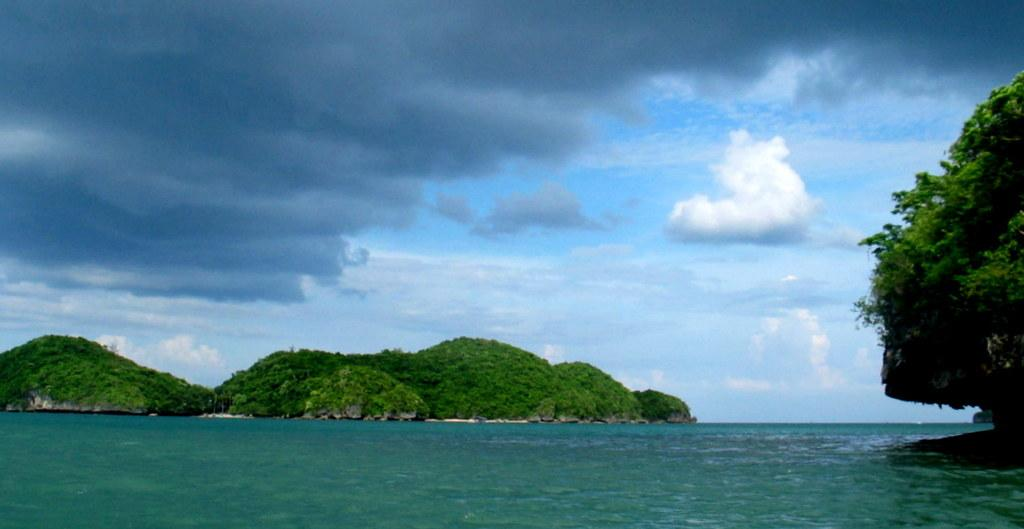What is the primary element visible in the image? There is water in the image. What type of landscape can be seen in the image? There are hills and trees in the image. What is visible in the background of the image? The sky is visible in the image. What can be observed in the sky? Clouds are present in the sky. What type of creature is hiding under the water in the image? There is no creature visible under the water in the image. What color is the brick used to build the house in the image? There is no house or brick present in the image. 